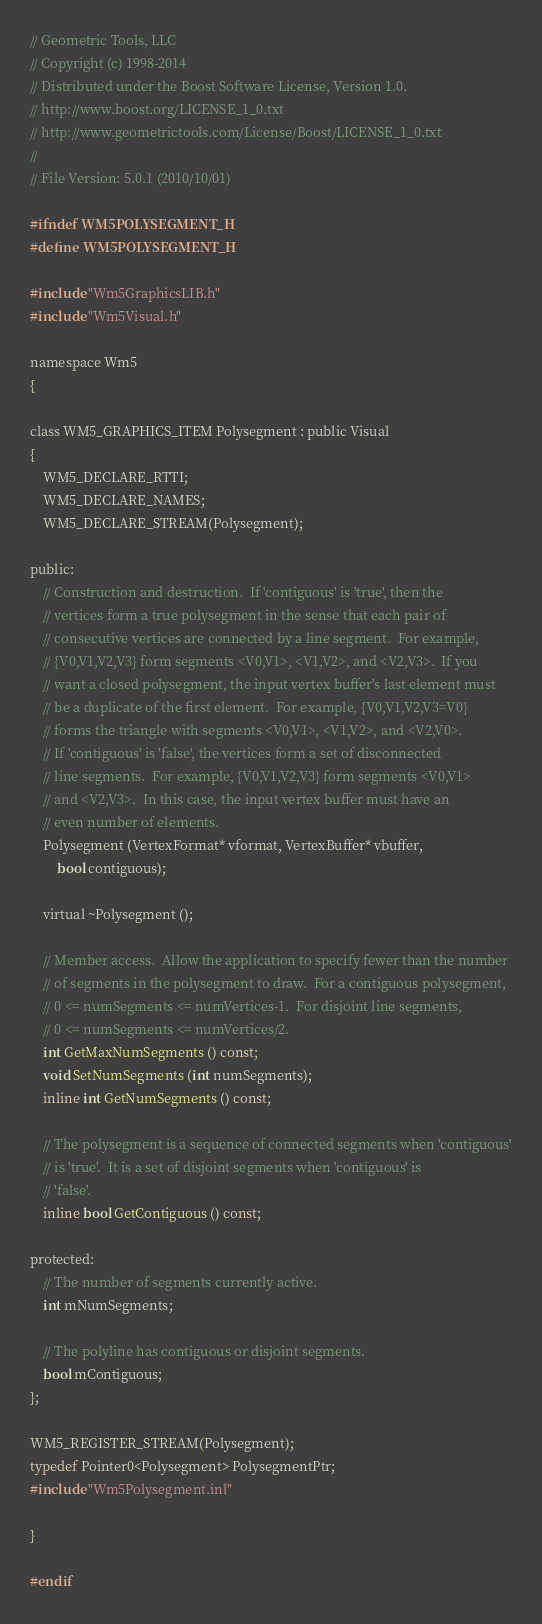<code> <loc_0><loc_0><loc_500><loc_500><_C_>// Geometric Tools, LLC
// Copyright (c) 1998-2014
// Distributed under the Boost Software License, Version 1.0.
// http://www.boost.org/LICENSE_1_0.txt
// http://www.geometrictools.com/License/Boost/LICENSE_1_0.txt
//
// File Version: 5.0.1 (2010/10/01)

#ifndef WM5POLYSEGMENT_H
#define WM5POLYSEGMENT_H

#include "Wm5GraphicsLIB.h"
#include "Wm5Visual.h"

namespace Wm5
{

class WM5_GRAPHICS_ITEM Polysegment : public Visual
{
    WM5_DECLARE_RTTI;
    WM5_DECLARE_NAMES;
    WM5_DECLARE_STREAM(Polysegment);

public:
    // Construction and destruction.  If 'contiguous' is 'true', then the
    // vertices form a true polysegment in the sense that each pair of
    // consecutive vertices are connected by a line segment.  For example,
    // {V0,V1,V2,V3} form segments <V0,V1>, <V1,V2>, and <V2,V3>.  If you
    // want a closed polysegment, the input vertex buffer's last element must
    // be a duplicate of the first element.  For example, {V0,V1,V2,V3=V0}
    // forms the triangle with segments <V0,V1>, <V1,V2>, and <V2,V0>.
    // If 'contiguous' is 'false', the vertices form a set of disconnected
    // line segments.  For example, {V0,V1,V2,V3} form segments <V0,V1>
    // and <V2,V3>.  In this case, the input vertex buffer must have an
    // even number of elements.
    Polysegment (VertexFormat* vformat, VertexBuffer* vbuffer,
        bool contiguous);

    virtual ~Polysegment ();

    // Member access.  Allow the application to specify fewer than the number
    // of segments in the polysegment to draw.  For a contiguous polysegment,
    // 0 <= numSegments <= numVertices-1.  For disjoint line segments,
    // 0 <= numSegments <= numVertices/2.
    int GetMaxNumSegments () const;
    void SetNumSegments (int numSegments);
    inline int GetNumSegments () const;

    // The polysegment is a sequence of connected segments when 'contiguous'
    // is 'true'.  It is a set of disjoint segments when 'contiguous' is
    // 'false'.
    inline bool GetContiguous () const;

protected:
    // The number of segments currently active.
    int mNumSegments;
    
    // The polyline has contiguous or disjoint segments.
    bool mContiguous;
};

WM5_REGISTER_STREAM(Polysegment);
typedef Pointer0<Polysegment> PolysegmentPtr;
#include "Wm5Polysegment.inl"

}

#endif
</code> 